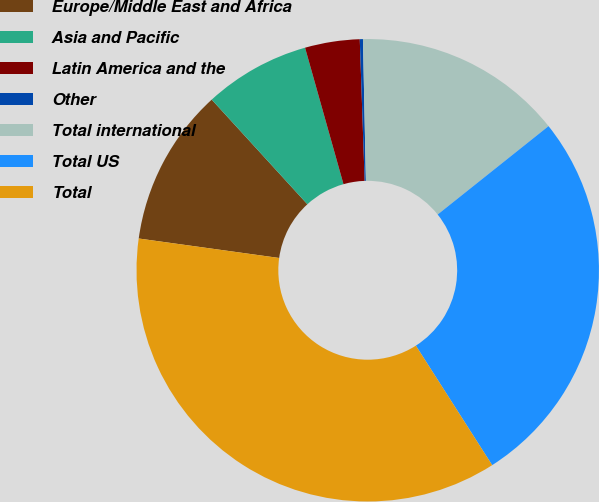Convert chart. <chart><loc_0><loc_0><loc_500><loc_500><pie_chart><fcel>Europe/Middle East and Africa<fcel>Asia and Pacific<fcel>Latin America and the<fcel>Other<fcel>Total international<fcel>Total US<fcel>Total<nl><fcel>11.02%<fcel>7.42%<fcel>3.82%<fcel>0.22%<fcel>14.62%<fcel>26.67%<fcel>36.24%<nl></chart> 